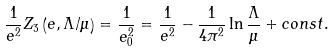Convert formula to latex. <formula><loc_0><loc_0><loc_500><loc_500>\frac { 1 } { e ^ { 2 } } Z _ { 3 } \left ( e , \Lambda / \mu \right ) = \frac { 1 } { e _ { 0 } ^ { 2 } } = \frac { 1 } { e ^ { 2 } } - \frac { 1 } { 4 \pi ^ { 2 } } \ln \frac { \Lambda } { \mu } + c o n s t .</formula> 